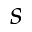Convert formula to latex. <formula><loc_0><loc_0><loc_500><loc_500>s</formula> 